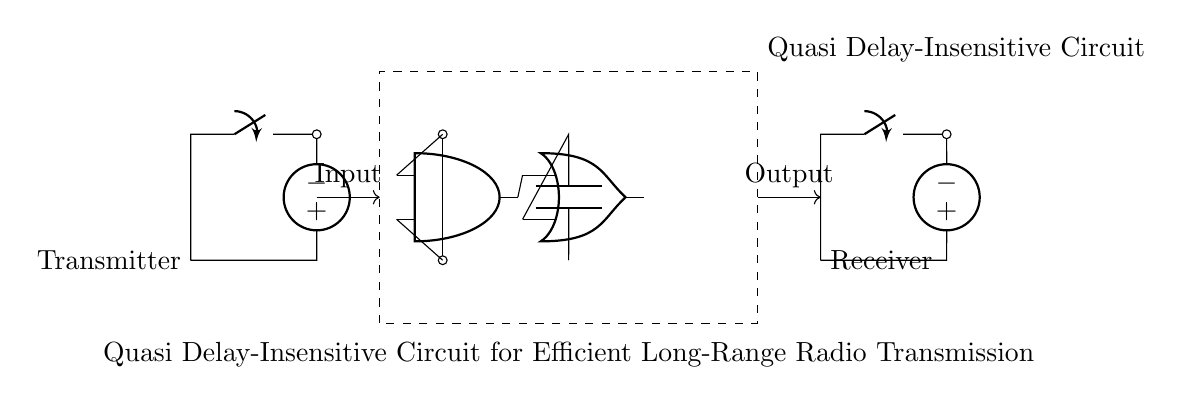What type of circuit is shown? The circuit is a quasi delay-insensitive circuit, as indicated by the label within the dashed rectangle in the diagram. This label represents the unique characteristic of this circuit design.
Answer: quasi delay-insensitive circuit What components are used in the circuit? The components in the circuit include an antenna, a switch, a voltage source, capacitors, AND gates, and OR gates. These elements can be identified through their symbols in the circuit.
Answer: antenna, switch, voltage source, capacitors, AND gate, OR gate How many AND gates are present in the circuit? There is one AND gate in the circuit, represented by the node labeled as "and1". The diagram shows only one such component within the quasi delay-insensitive circuit.
Answer: one What is the role of the capacitor in this circuit? The capacitor in the circuit is connected between the output of an input line and an OR gate, which typically helps in stabilizing signals and providing timing delay, essential for delay-insensitive operation.
Answer: stabilizing signals What do the arrows in the circuit signify? The arrows indicate the direction of signal flow from the input to the output, illustrating how the signals are processed through the various components in the circuit.
Answer: signal flow What is the function of the OR gate in this circuit? The OR gate combines signals from the AND gate and the capacitor, allowing for output when at least one input is active. This is crucial for achieving logic in delay-insensitive circuits, where multiple paths may affect the eventual output.
Answer: combining signals What type of transmission does this circuit facilitate? This circuit facilitates long-range radio transmission, as stated in the label at the bottom of the circuit. This describes the overarching purpose of the circuit design.
Answer: long-range radio transmission 